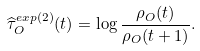Convert formula to latex. <formula><loc_0><loc_0><loc_500><loc_500>\widehat { \tau } _ { O } ^ { e x p ( 2 ) } ( t ) = \log \frac { \rho _ { O } ( t ) } { \rho _ { O } ( t + 1 ) } .</formula> 